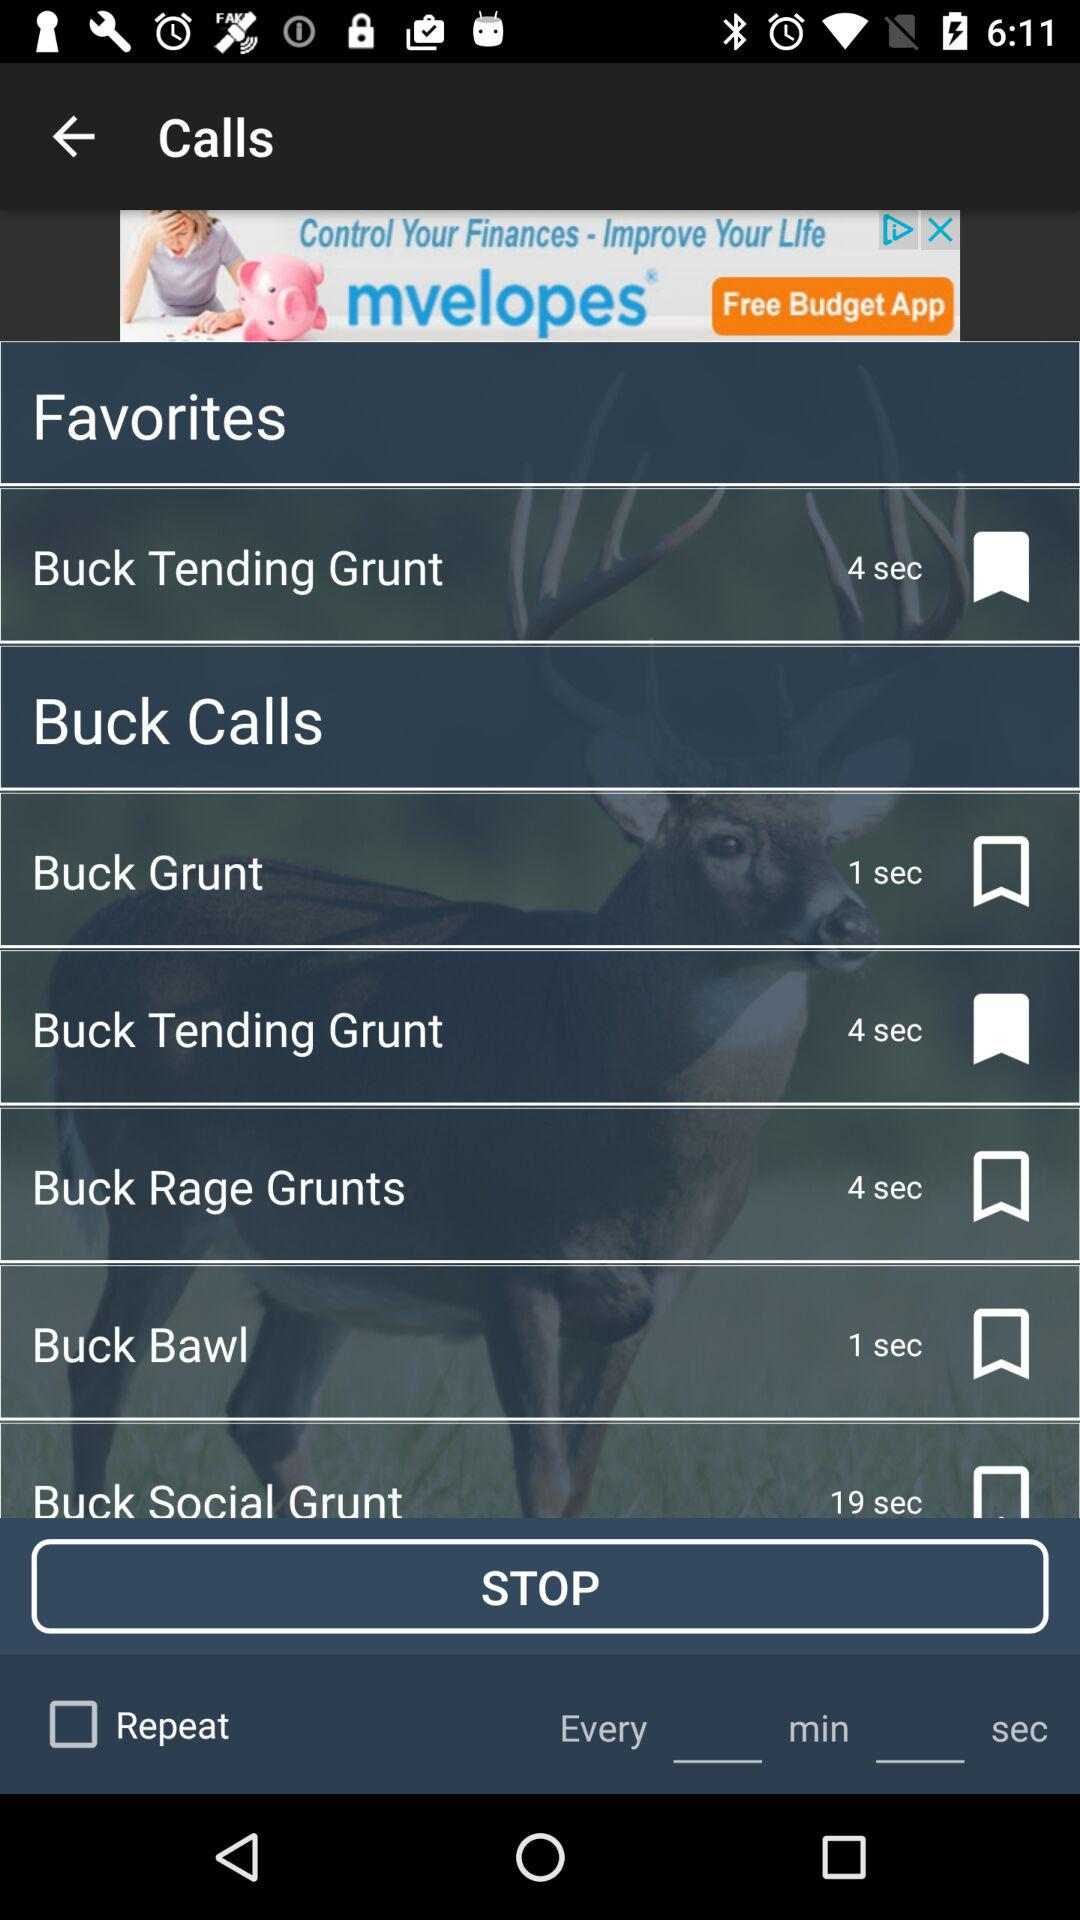How many seconds are in the longest call?
Answer the question using a single word or phrase. 19 